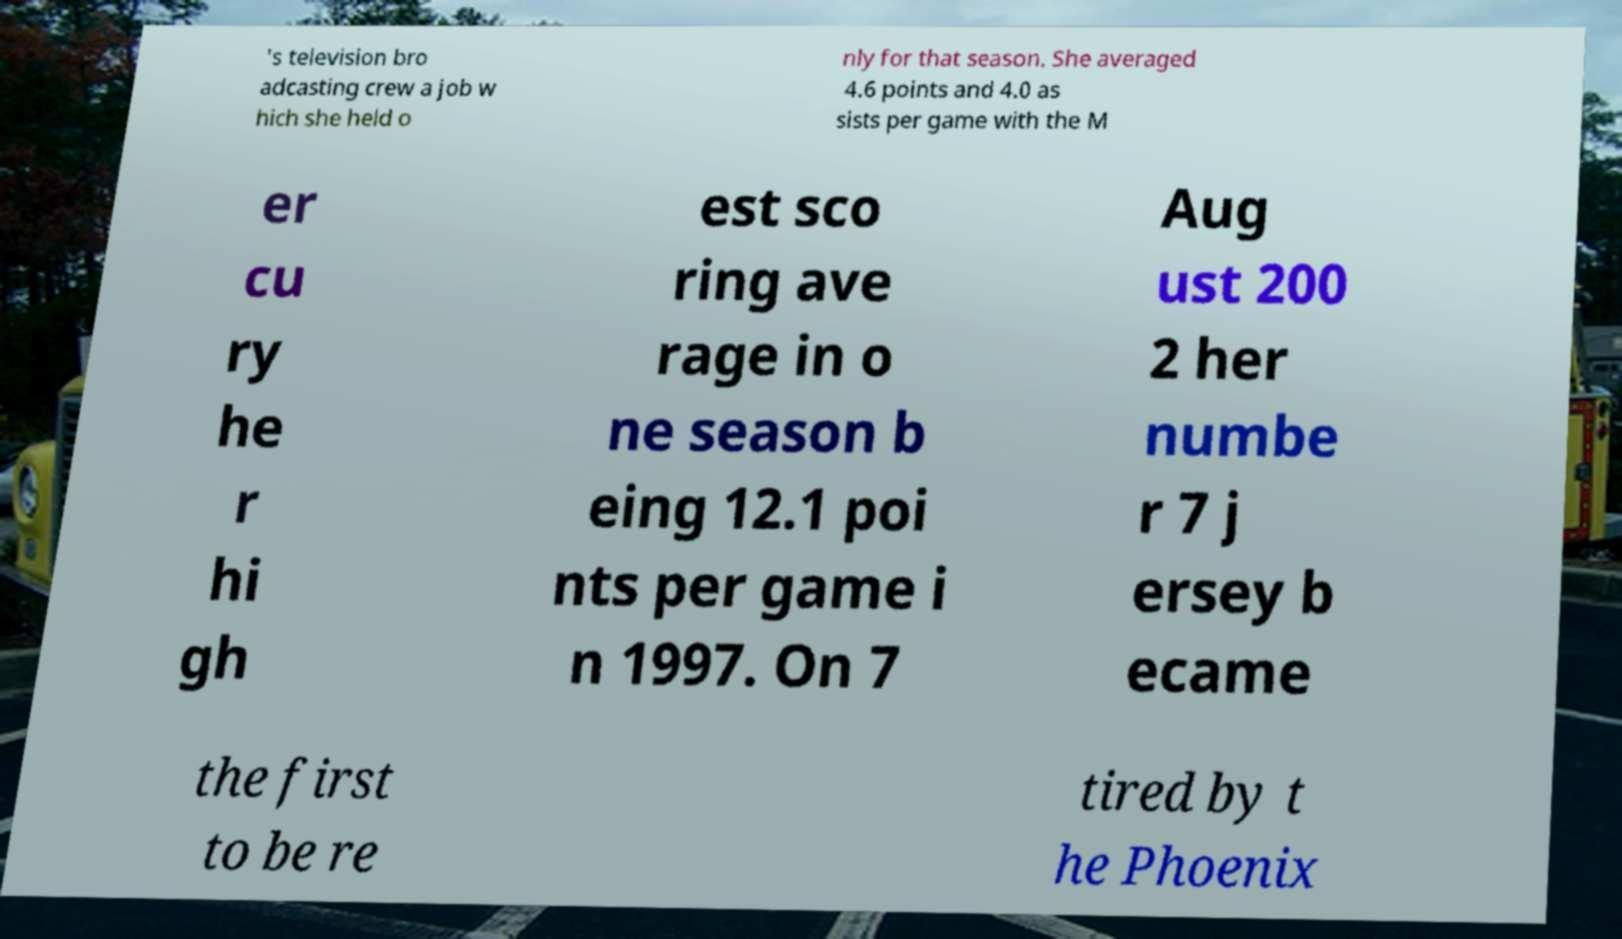I need the written content from this picture converted into text. Can you do that? 's television bro adcasting crew a job w hich she held o nly for that season. She averaged 4.6 points and 4.0 as sists per game with the M er cu ry he r hi gh est sco ring ave rage in o ne season b eing 12.1 poi nts per game i n 1997. On 7 Aug ust 200 2 her numbe r 7 j ersey b ecame the first to be re tired by t he Phoenix 